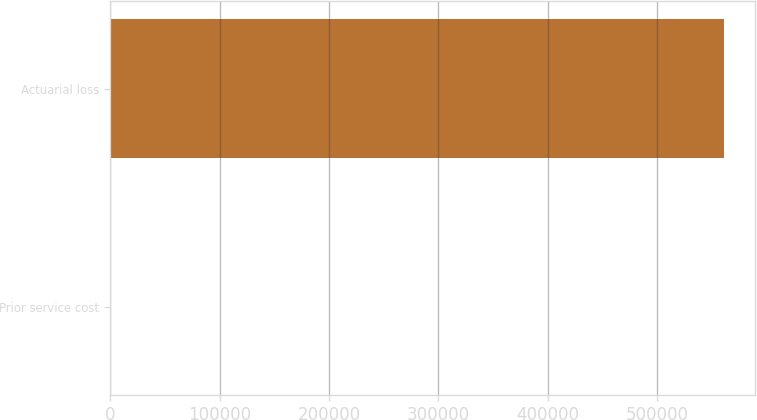Convert chart. <chart><loc_0><loc_0><loc_500><loc_500><bar_chart><fcel>Prior service cost<fcel>Actuarial loss<nl><fcel>226<fcel>561473<nl></chart> 